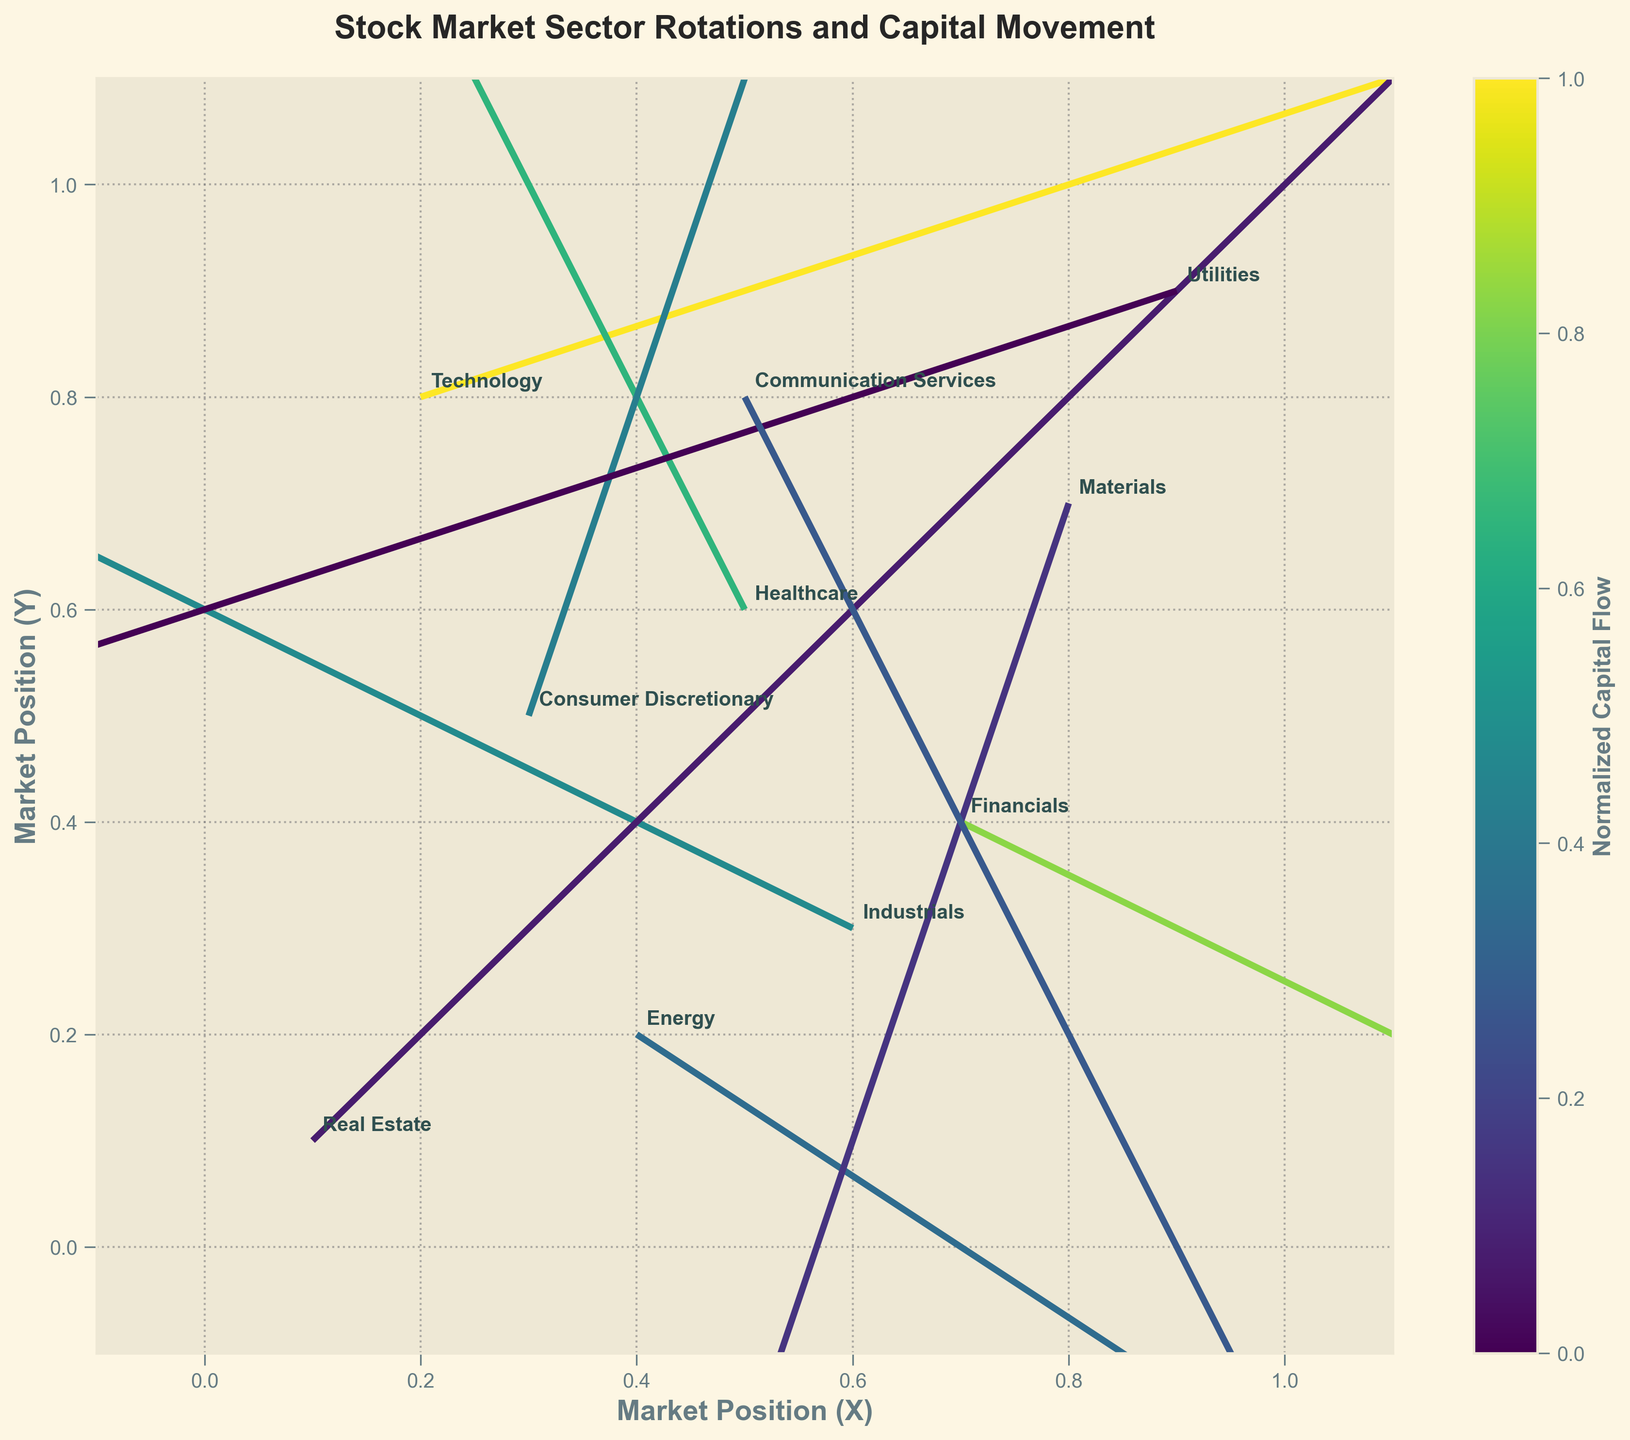What's the title of the figure? The title of the figure is written as a header at the top of the plot.
Answer: Stock Market Sector Rotations and Capital Movement How many sectors are represented in the figure? There is one annotated label for each sector in the plot, and counting these labels will give the total number of sectors.
Answer: 10 Which sector has the highest value of normalized capital flow? The color intensity in the plot indicates the normalized capital flow, with higher values represented by brighter colors. The sector 'Technology' has the highest color intensity, corresponding to the highest capital flow.
Answer: Technology What is the X and Y position of the 'Energy' sector? The position of each sector can be determined by looking at the annotated labels and finding the location on the XY plane. The 'Energy' sector is positioned at X=0.4 and Y=0.2.
Answer: X=0.4, Y=0.2 Which sectors have a negative change in their X position (DX)? By looking at the arrows' directions and noting sectors with arrows pointing towards the left (negative X direction), the sectors with a negative DX are 'Healthcare', 'Industrials', 'Materials', and 'Utilities'.
Answer: Healthcare, Industrials, Materials, Utilities What is the magnitude of the change in the Y position for 'Consumer Discretionary'? The length of the arrow in the Y direction for the 'Consumer Discretionary' sector can be visually inspected, and it corresponds to DY=0.3.
Answer: 0.3 Which sector shows a net movement to the upper-left quadrant? A net movement to the upper-left quadrant indicates a negative change in the X position and a positive change in the Y position. The 'Healthcare' sector meets this criterion since DX=-0.1 and DY=0.2.
Answer: Healthcare Compare the normalized capital flows between 'Communication Services' and 'Consumer Discretionary'. Which one is higher? The color intensity related to these sectors indicates the normalized capital flow. 'Consumer Discretionary' shows a higher intensity, indicating a higher flow compared to 'Communication Services'.
Answer: Consumer Discretionary Which sector shows a movement vector in the direction towards the right and downwards? The direction of the arrow across sectors indicates their movement. The vectors pointing towards the right and downwards should have both positive DX and negative DY. This applies to the 'Energy' sector.
Answer: Energy If you sum the capital flows of 'Technology' and 'Financials', what is the total? By adding the capital flows provided in the data set, Technology has a flow of 5.2 and Financials has a flow of 4.5. Summing these values results in 5.2 + 4.5 = 9.7.
Answer: 9.7 